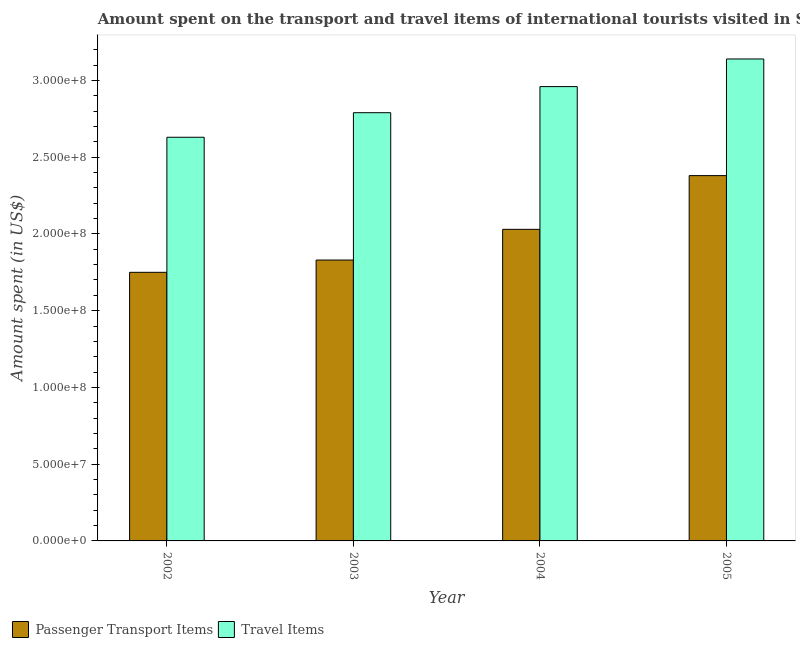How many different coloured bars are there?
Make the answer very short. 2. Are the number of bars on each tick of the X-axis equal?
Your answer should be very brief. Yes. How many bars are there on the 1st tick from the left?
Offer a terse response. 2. How many bars are there on the 1st tick from the right?
Your answer should be very brief. 2. What is the label of the 1st group of bars from the left?
Offer a very short reply. 2002. What is the amount spent in travel items in 2002?
Give a very brief answer. 2.63e+08. Across all years, what is the maximum amount spent in travel items?
Ensure brevity in your answer.  3.14e+08. Across all years, what is the minimum amount spent in travel items?
Offer a very short reply. 2.63e+08. In which year was the amount spent in travel items maximum?
Your answer should be compact. 2005. What is the total amount spent on passenger transport items in the graph?
Provide a short and direct response. 7.99e+08. What is the difference between the amount spent in travel items in 2003 and that in 2005?
Offer a terse response. -3.50e+07. What is the difference between the amount spent on passenger transport items in 2003 and the amount spent in travel items in 2004?
Give a very brief answer. -2.00e+07. What is the average amount spent on passenger transport items per year?
Keep it short and to the point. 2.00e+08. What is the ratio of the amount spent on passenger transport items in 2003 to that in 2005?
Your response must be concise. 0.77. Is the difference between the amount spent in travel items in 2003 and 2005 greater than the difference between the amount spent on passenger transport items in 2003 and 2005?
Your answer should be compact. No. What is the difference between the highest and the second highest amount spent in travel items?
Give a very brief answer. 1.80e+07. What is the difference between the highest and the lowest amount spent on passenger transport items?
Ensure brevity in your answer.  6.30e+07. What does the 2nd bar from the left in 2002 represents?
Your response must be concise. Travel Items. What does the 2nd bar from the right in 2004 represents?
Make the answer very short. Passenger Transport Items. How many bars are there?
Your answer should be very brief. 8. Are all the bars in the graph horizontal?
Provide a succinct answer. No. How many years are there in the graph?
Your answer should be very brief. 4. What is the difference between two consecutive major ticks on the Y-axis?
Offer a terse response. 5.00e+07. Are the values on the major ticks of Y-axis written in scientific E-notation?
Your answer should be compact. Yes. Does the graph contain any zero values?
Offer a terse response. No. Does the graph contain grids?
Your answer should be very brief. No. What is the title of the graph?
Provide a succinct answer. Amount spent on the transport and travel items of international tourists visited in Sri Lanka. Does "US$" appear as one of the legend labels in the graph?
Make the answer very short. No. What is the label or title of the Y-axis?
Your response must be concise. Amount spent (in US$). What is the Amount spent (in US$) in Passenger Transport Items in 2002?
Keep it short and to the point. 1.75e+08. What is the Amount spent (in US$) of Travel Items in 2002?
Ensure brevity in your answer.  2.63e+08. What is the Amount spent (in US$) of Passenger Transport Items in 2003?
Give a very brief answer. 1.83e+08. What is the Amount spent (in US$) in Travel Items in 2003?
Your answer should be compact. 2.79e+08. What is the Amount spent (in US$) of Passenger Transport Items in 2004?
Provide a short and direct response. 2.03e+08. What is the Amount spent (in US$) in Travel Items in 2004?
Provide a succinct answer. 2.96e+08. What is the Amount spent (in US$) of Passenger Transport Items in 2005?
Your response must be concise. 2.38e+08. What is the Amount spent (in US$) in Travel Items in 2005?
Your response must be concise. 3.14e+08. Across all years, what is the maximum Amount spent (in US$) of Passenger Transport Items?
Provide a short and direct response. 2.38e+08. Across all years, what is the maximum Amount spent (in US$) in Travel Items?
Your answer should be very brief. 3.14e+08. Across all years, what is the minimum Amount spent (in US$) in Passenger Transport Items?
Your answer should be very brief. 1.75e+08. Across all years, what is the minimum Amount spent (in US$) in Travel Items?
Offer a very short reply. 2.63e+08. What is the total Amount spent (in US$) of Passenger Transport Items in the graph?
Keep it short and to the point. 7.99e+08. What is the total Amount spent (in US$) of Travel Items in the graph?
Offer a very short reply. 1.15e+09. What is the difference between the Amount spent (in US$) in Passenger Transport Items in 2002 and that in 2003?
Keep it short and to the point. -8.00e+06. What is the difference between the Amount spent (in US$) of Travel Items in 2002 and that in 2003?
Provide a succinct answer. -1.60e+07. What is the difference between the Amount spent (in US$) of Passenger Transport Items in 2002 and that in 2004?
Ensure brevity in your answer.  -2.80e+07. What is the difference between the Amount spent (in US$) of Travel Items in 2002 and that in 2004?
Your response must be concise. -3.30e+07. What is the difference between the Amount spent (in US$) of Passenger Transport Items in 2002 and that in 2005?
Your answer should be compact. -6.30e+07. What is the difference between the Amount spent (in US$) of Travel Items in 2002 and that in 2005?
Make the answer very short. -5.10e+07. What is the difference between the Amount spent (in US$) of Passenger Transport Items in 2003 and that in 2004?
Your answer should be compact. -2.00e+07. What is the difference between the Amount spent (in US$) of Travel Items in 2003 and that in 2004?
Offer a terse response. -1.70e+07. What is the difference between the Amount spent (in US$) in Passenger Transport Items in 2003 and that in 2005?
Give a very brief answer. -5.50e+07. What is the difference between the Amount spent (in US$) of Travel Items in 2003 and that in 2005?
Keep it short and to the point. -3.50e+07. What is the difference between the Amount spent (in US$) in Passenger Transport Items in 2004 and that in 2005?
Keep it short and to the point. -3.50e+07. What is the difference between the Amount spent (in US$) in Travel Items in 2004 and that in 2005?
Make the answer very short. -1.80e+07. What is the difference between the Amount spent (in US$) of Passenger Transport Items in 2002 and the Amount spent (in US$) of Travel Items in 2003?
Keep it short and to the point. -1.04e+08. What is the difference between the Amount spent (in US$) of Passenger Transport Items in 2002 and the Amount spent (in US$) of Travel Items in 2004?
Your answer should be compact. -1.21e+08. What is the difference between the Amount spent (in US$) in Passenger Transport Items in 2002 and the Amount spent (in US$) in Travel Items in 2005?
Keep it short and to the point. -1.39e+08. What is the difference between the Amount spent (in US$) of Passenger Transport Items in 2003 and the Amount spent (in US$) of Travel Items in 2004?
Give a very brief answer. -1.13e+08. What is the difference between the Amount spent (in US$) of Passenger Transport Items in 2003 and the Amount spent (in US$) of Travel Items in 2005?
Make the answer very short. -1.31e+08. What is the difference between the Amount spent (in US$) in Passenger Transport Items in 2004 and the Amount spent (in US$) in Travel Items in 2005?
Your response must be concise. -1.11e+08. What is the average Amount spent (in US$) in Passenger Transport Items per year?
Make the answer very short. 2.00e+08. What is the average Amount spent (in US$) of Travel Items per year?
Your answer should be compact. 2.88e+08. In the year 2002, what is the difference between the Amount spent (in US$) in Passenger Transport Items and Amount spent (in US$) in Travel Items?
Provide a succinct answer. -8.80e+07. In the year 2003, what is the difference between the Amount spent (in US$) of Passenger Transport Items and Amount spent (in US$) of Travel Items?
Offer a terse response. -9.60e+07. In the year 2004, what is the difference between the Amount spent (in US$) in Passenger Transport Items and Amount spent (in US$) in Travel Items?
Ensure brevity in your answer.  -9.30e+07. In the year 2005, what is the difference between the Amount spent (in US$) of Passenger Transport Items and Amount spent (in US$) of Travel Items?
Offer a terse response. -7.60e+07. What is the ratio of the Amount spent (in US$) in Passenger Transport Items in 2002 to that in 2003?
Give a very brief answer. 0.96. What is the ratio of the Amount spent (in US$) in Travel Items in 2002 to that in 2003?
Offer a very short reply. 0.94. What is the ratio of the Amount spent (in US$) in Passenger Transport Items in 2002 to that in 2004?
Give a very brief answer. 0.86. What is the ratio of the Amount spent (in US$) of Travel Items in 2002 to that in 2004?
Keep it short and to the point. 0.89. What is the ratio of the Amount spent (in US$) of Passenger Transport Items in 2002 to that in 2005?
Your answer should be very brief. 0.74. What is the ratio of the Amount spent (in US$) of Travel Items in 2002 to that in 2005?
Keep it short and to the point. 0.84. What is the ratio of the Amount spent (in US$) in Passenger Transport Items in 2003 to that in 2004?
Provide a succinct answer. 0.9. What is the ratio of the Amount spent (in US$) of Travel Items in 2003 to that in 2004?
Your answer should be very brief. 0.94. What is the ratio of the Amount spent (in US$) of Passenger Transport Items in 2003 to that in 2005?
Provide a short and direct response. 0.77. What is the ratio of the Amount spent (in US$) of Travel Items in 2003 to that in 2005?
Make the answer very short. 0.89. What is the ratio of the Amount spent (in US$) in Passenger Transport Items in 2004 to that in 2005?
Ensure brevity in your answer.  0.85. What is the ratio of the Amount spent (in US$) of Travel Items in 2004 to that in 2005?
Your answer should be compact. 0.94. What is the difference between the highest and the second highest Amount spent (in US$) in Passenger Transport Items?
Your answer should be compact. 3.50e+07. What is the difference between the highest and the second highest Amount spent (in US$) of Travel Items?
Offer a terse response. 1.80e+07. What is the difference between the highest and the lowest Amount spent (in US$) of Passenger Transport Items?
Your response must be concise. 6.30e+07. What is the difference between the highest and the lowest Amount spent (in US$) of Travel Items?
Your answer should be very brief. 5.10e+07. 